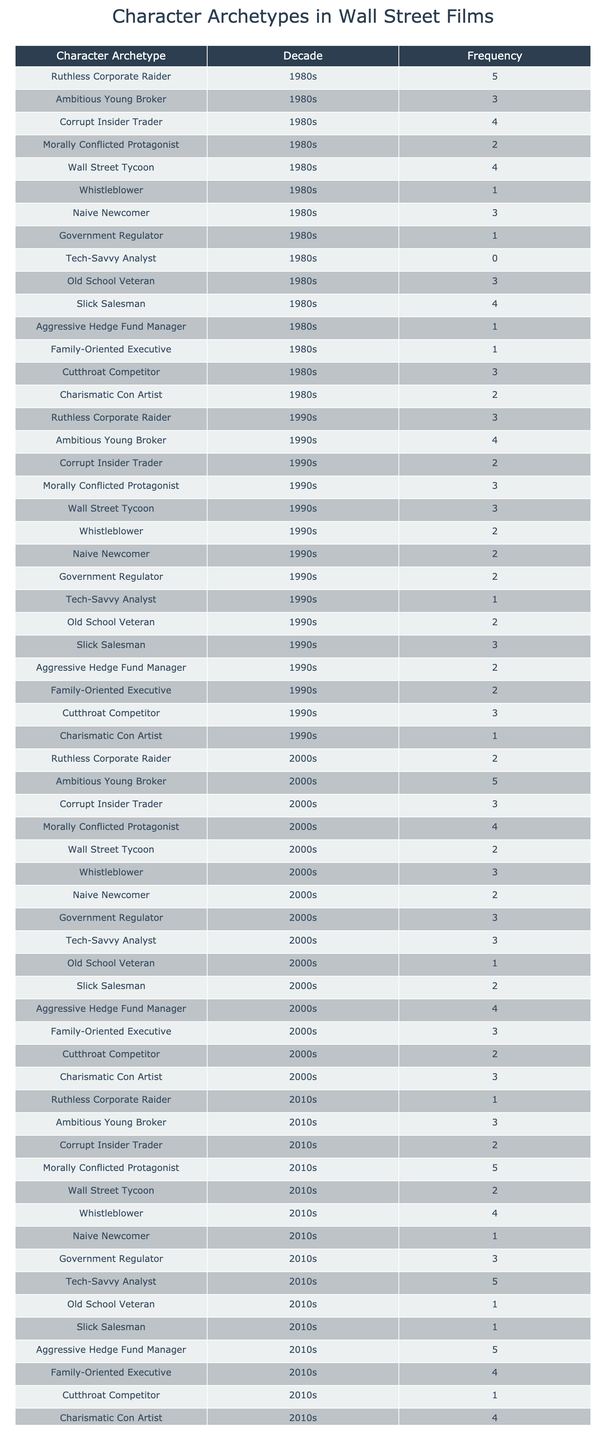What character archetype had the highest frequency in the 1980s? The highest frequency in the 1980s is associated with the "Ruthless Corporate Raider," which has a frequency of 5.
Answer: Ruthless Corporate Raider Which character archetype saw an increase in frequency from the 1980s to the 2010s? The "Ambitious Young Broker" increased from 3 in the 1980s to 5 in the 2000s before decreasing to 3 in the 2010s.
Answer: Ambitious Young Broker Is it true that "Whistleblower" was more common in the 2010s than in the 1990s? Yes, the frequency of the "Whistleblower" archetype increased from 2 in the 1990s to 4 in the 2010s.
Answer: Yes What is the total frequency of "Morally Conflicted Protagonist" across all decades? To find the total frequency, we sum the values across decades: 2 + 3 + 4 + 5 = 14.
Answer: 14 Which two archetypes had the same frequency of 3 in the 2000s? The "Corrupt Insider Trader" and "Family-Oriented Executive" both have a frequency of 3 in the 2000s.
Answer: Corrupt Insider Trader and Family-Oriented Executive What is the average frequency of "Tech-Savvy Analyst" across all decades? The average frequency is calculated by summing the frequencies: 0 + 1 + 3 + 5 = 9, then dividing by 4 (decades), resulting in an average of 9/4 = 2.25.
Answer: 2.25 Which character archetype had the least frequency in the 1980s? The "Tech-Savvy Analyst" had a frequency of 0 in the 1980s, which is the least among all archetypes.
Answer: Tech-Savvy Analyst Did "Cutthroat Competitor" remain consistent across the decades? No, the "Cutthroat Competitor" had a frequency of 3 in the 1980s and 1990s but dropped to 2 in the 2000s and 1 in the 2010s, indicating a decline.
Answer: No How many archetypes had more than 4 appearances in the 1990s? In the 1990s, "Ambitious Young Broker" (4), "Ruthless Corporate Raider" (3), and "Slick Salesman" (3) were the only archetypes, so "Ambitious Young Broker" is the only one appearing more than 4 times. Thus, the answer is 1.
Answer: 1 Which decade has the highest total frequency for all archetypes combined? By summing the frequencies per decade: 1980s (34), 1990s (29), 2000s (27), and 2010s (27). The highest total occurred in the 1980s with 34.
Answer: 1980s 